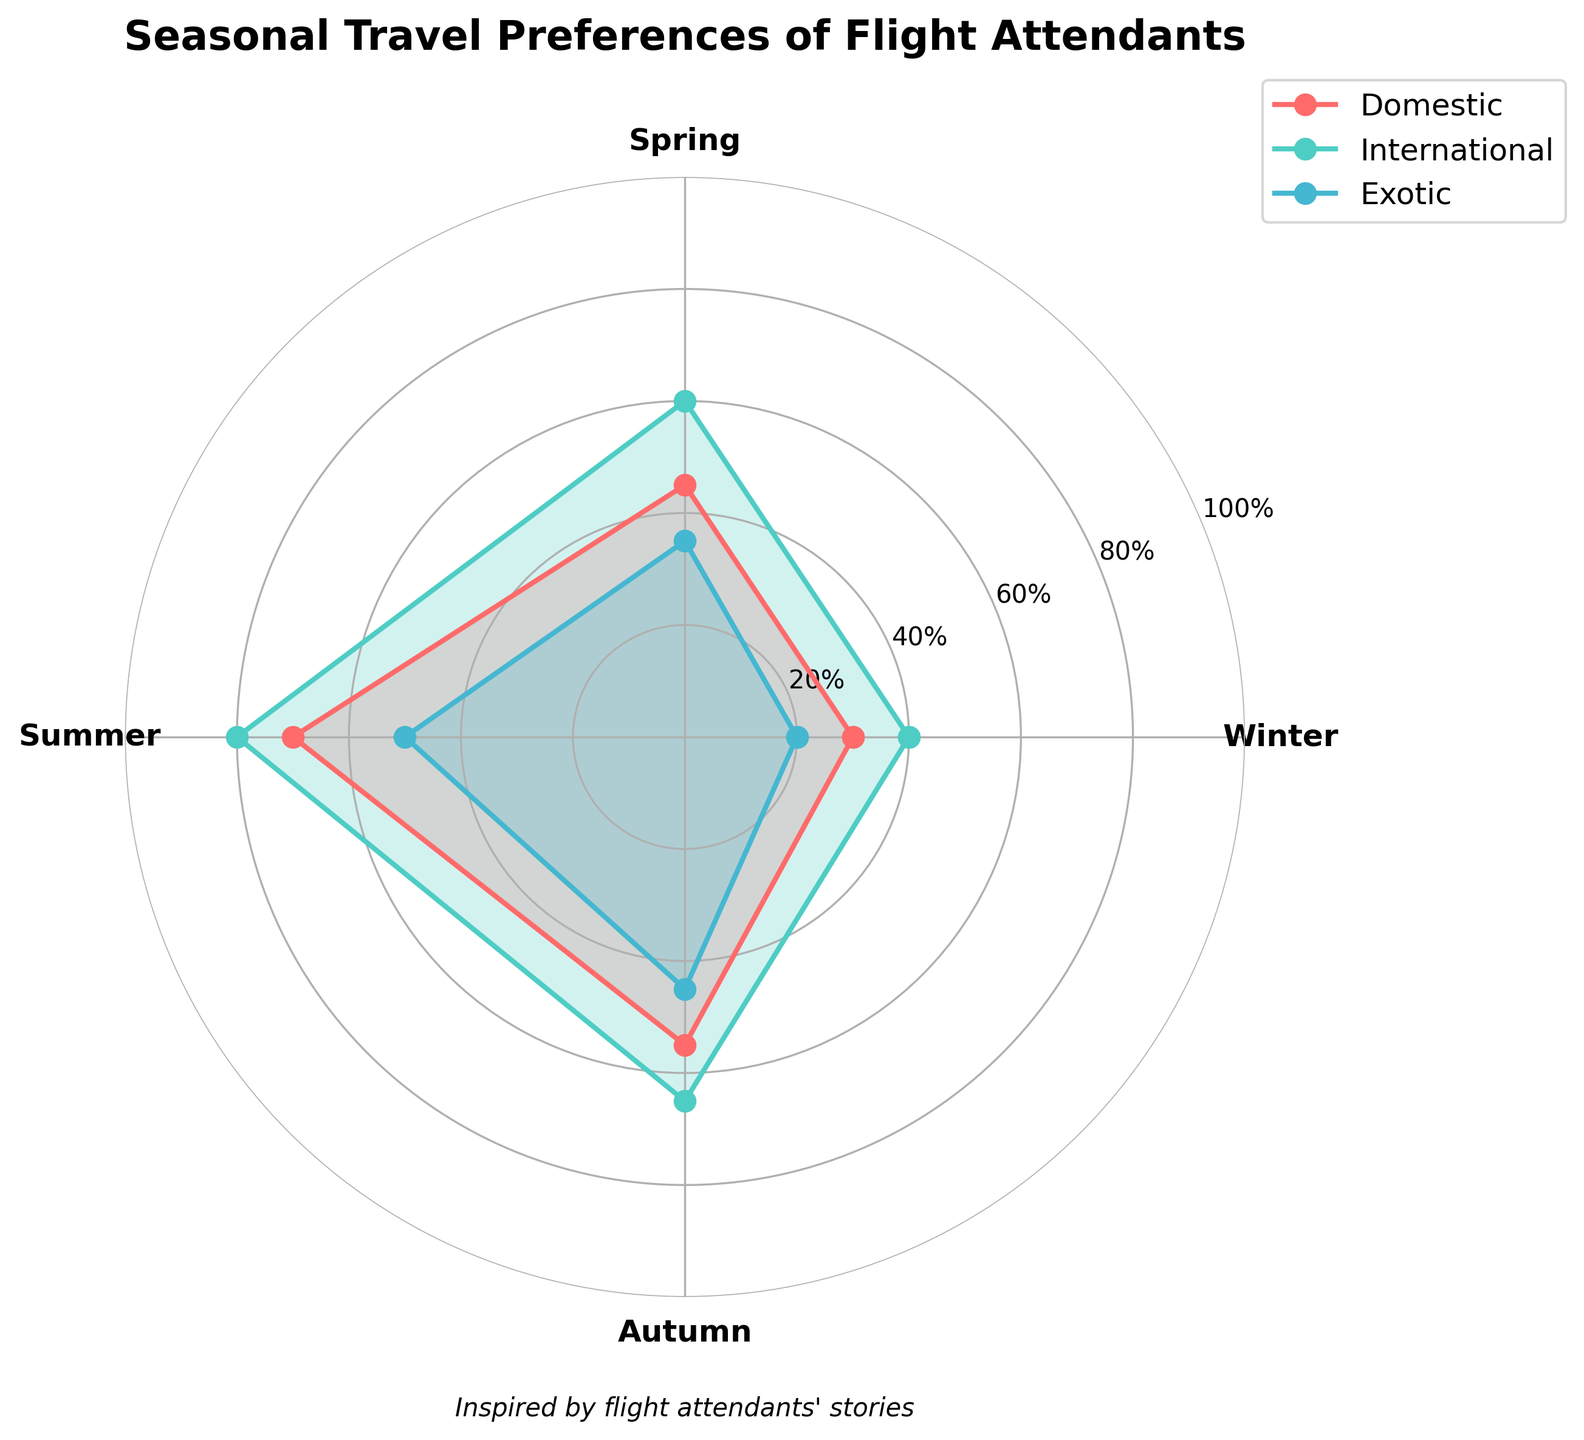What is the title of the figure? The title is usually at the top of the figure. In this case, it is clearly stated, giving an overview of what the chart represents.
Answer: Seasonal Travel Preferences of Flight Attendants Which destination type has the highest preference percentage in winter? Look at the segment of the rose chart labeled 'Winter' and compare the values for Domestic, International, and Exotic destination types.
Answer: International How do the preferences for Domestic travel in Spring and Autumn compare? Identify the values for Domestic destination type in Spring and Autumn. Spring is 45%, and Autumn is 55%.
Answer: Autumn is 10% higher What are the preference percentages for Exotic destinations across all seasons? Read the values representing Exotic destinations in each of the seasonal segments of the rose chart.
Answer: 20%, 35%, 50%, 45% Which season has the highest overall travel preference regardless of the destination type? Sum the preference percentages for all destination types in each season and compare. Winter: 30+40+20 = 90; Spring: 45+60+35 = 140; Summer: 70+80+50 = 200; Autumn: 55+65+45 = 165.
Answer: Summer Are Domestic travel preferences higher in Spring or Winter? Compare the values for Domestic travel in Spring (45%) and Winter (30%).
Answer: Spring For which destination type do travel preferences fluctuate the least across seasons? Find the range (difference between the maximum and minimum values) for each destination type and compare. Domestic: 70-30=40, International: 80-40=40, Exotic: 50-20=30.
Answer: Exotic What is the sum of preferences for International travel in Summer and Autumn? Read the values for International travel in Summer (80%) and Autumn (65%), then add them.
Answer: 145% Which season has the lowest preference percentage for Exotic destinations? Identify the smallest value among the percentages for Exotic destinations in Winter, Spring, Summer, and Autumn.
Answer: Winter How does the preference for International travel in Spring compare to Domestic travel in Summer? Compare the values: International in Spring (60%) and Domestic in Summer (70%).
Answer: Domestic in Summer is higher 